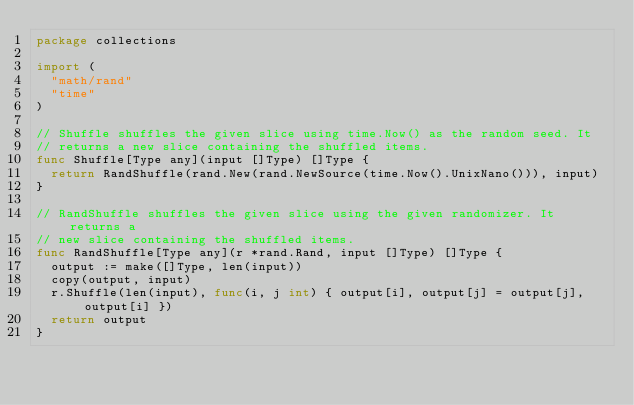<code> <loc_0><loc_0><loc_500><loc_500><_Go_>package collections

import (
	"math/rand"
	"time"
)

// Shuffle shuffles the given slice using time.Now() as the random seed. It
// returns a new slice containing the shuffled items.
func Shuffle[Type any](input []Type) []Type {
	return RandShuffle(rand.New(rand.NewSource(time.Now().UnixNano())), input)
}

// RandShuffle shuffles the given slice using the given randomizer. It returns a
// new slice containing the shuffled items.
func RandShuffle[Type any](r *rand.Rand, input []Type) []Type {
	output := make([]Type, len(input))
	copy(output, input)
	r.Shuffle(len(input), func(i, j int) { output[i], output[j] = output[j], output[i] })
	return output
}
</code> 